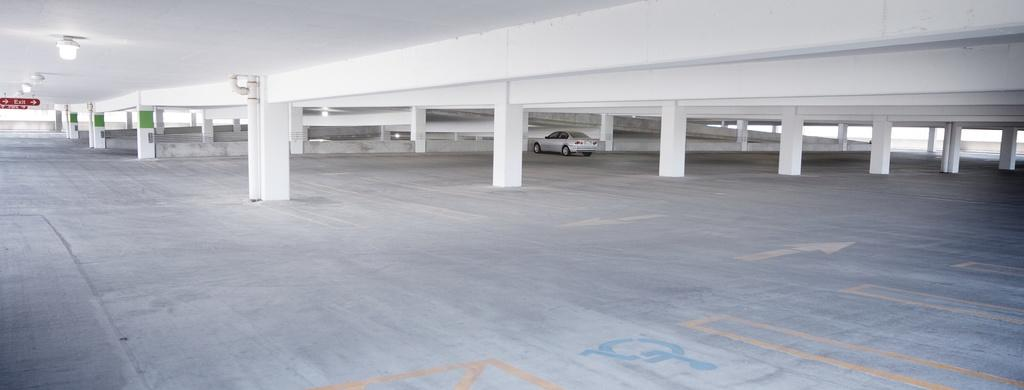What is parked in the image? There is a car parked in the image. Where is the car located? The car is on the floor in the image. What other structures can be seen in the image? There are pillars in the image. What can be used for illumination in the image? There are lights in the image. What type of information might be conveyed by the sign boards in the image? The sign boards attached to the ceiling in the image might convey information or directions. What type of juice is being served to the family in the image? There is no family or juice present in the image; it features a parked car and other structural elements. 